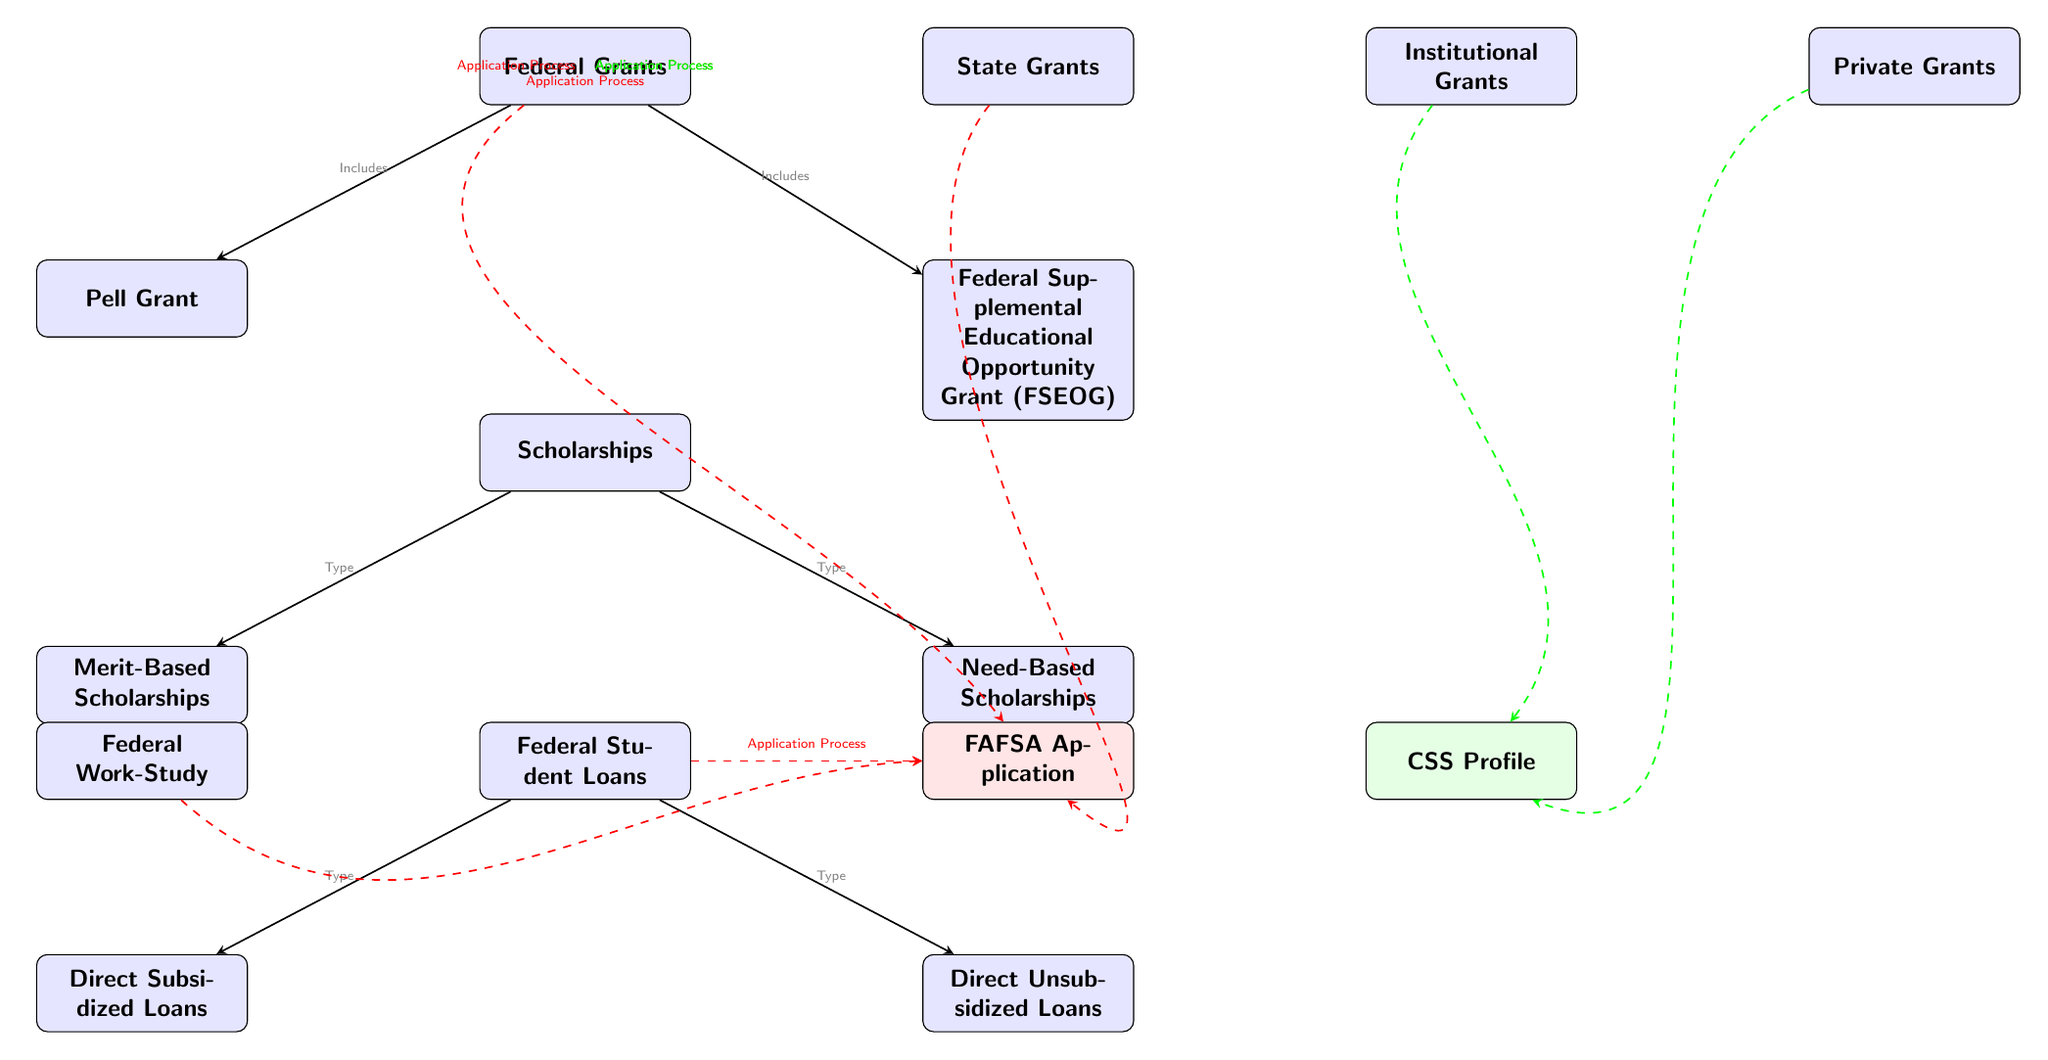What are the two types of Federal Grants listed? The diagram distinctly states that the two types of Federal Grants are the Pell Grant and the Federal Supplemental Educational Opportunity Grant (FSEOG).
Answer: Pell Grant and FSEOG How many types of scholarships are mentioned in the diagram? The diagram specifies two types of scholarships: Merit-Based and Need-Based, indicating the total count of scholarship types included.
Answer: 2 What is the application process for Federal Grants? Federal Grants require the FAFSA Application as the application process, which is indicated by a dashed red line connecting Federal Grants to the FAFSA Application.
Answer: FAFSA Application Which types of loans are under Federal Student Loans? The diagram identifies two categories of Federal Student Loans: Direct Subsidized Loans and Direct Unsubsidized Loans, both connected to the Federal Student Loans node.
Answer: Direct Subsidized Loans and Direct Unsubsidized Loans What is required for State Grants in terms of application? The diagram shows a dashed red edge from State Grants to the FAFSA Application, confirming that the State Grants' application process requires completing the FAFSA.
Answer: FAFSA Application What type of application is needed for Institutional and Private Grants? Both Institutional Grants and Private Grants direct their application processes through the CSS Profile, as indicated by the dashed green edges connecting them to the CSS Profile.
Answer: CSS Profile How many main categories of financial aid are presented in the diagram? Looking at the diagram, we see four main categories presented: Federal Grants, State Grants, Institutional Grants, and Private Grants, alongside scholarships and loans.
Answer: 4 What is the common application process for Federal Work-Study and Federal Loans? Both Federal Work-Study and Federal Loans require the FAFSA Application as the application process, which is evidenced by the dashed red lines leading to the FAFSA Application from these financial aids.
Answer: FAFSA Application 